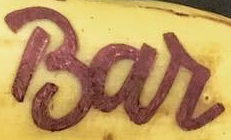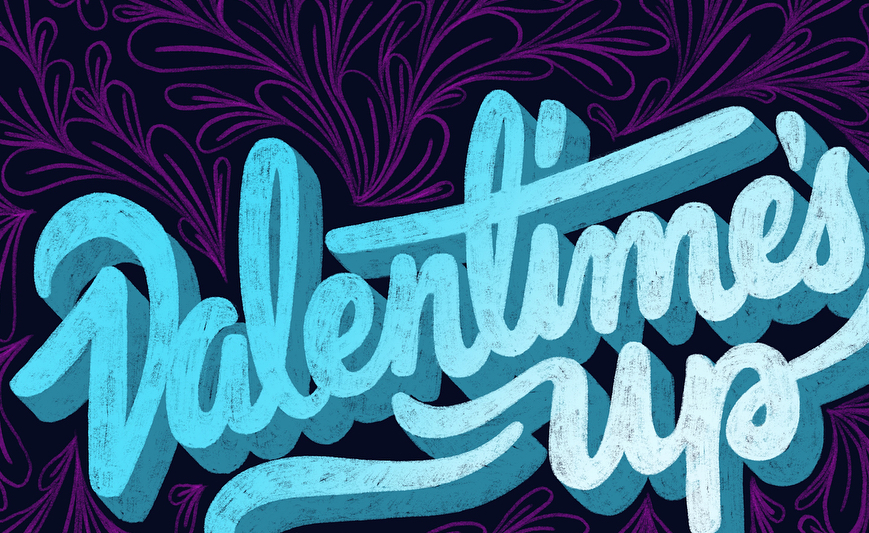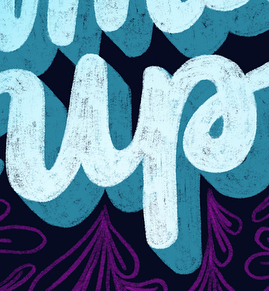Identify the words shown in these images in order, separated by a semicolon. Bar; Valentime's; up 